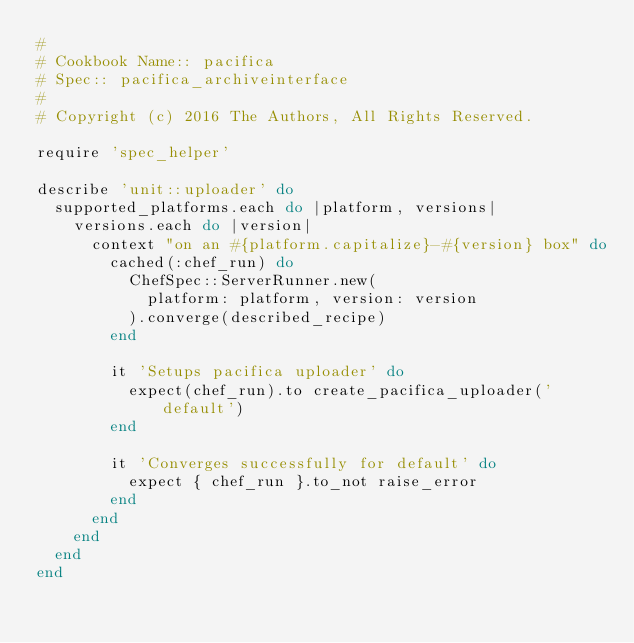<code> <loc_0><loc_0><loc_500><loc_500><_Ruby_>#
# Cookbook Name:: pacifica
# Spec:: pacifica_archiveinterface
#
# Copyright (c) 2016 The Authors, All Rights Reserved.

require 'spec_helper'

describe 'unit::uploader' do
  supported_platforms.each do |platform, versions|
    versions.each do |version|
      context "on an #{platform.capitalize}-#{version} box" do
        cached(:chef_run) do
          ChefSpec::ServerRunner.new(
            platform: platform, version: version
          ).converge(described_recipe)
        end

        it 'Setups pacifica uploader' do
          expect(chef_run).to create_pacifica_uploader('default')
        end

        it 'Converges successfully for default' do
          expect { chef_run }.to_not raise_error
        end
      end
    end
  end
end
</code> 